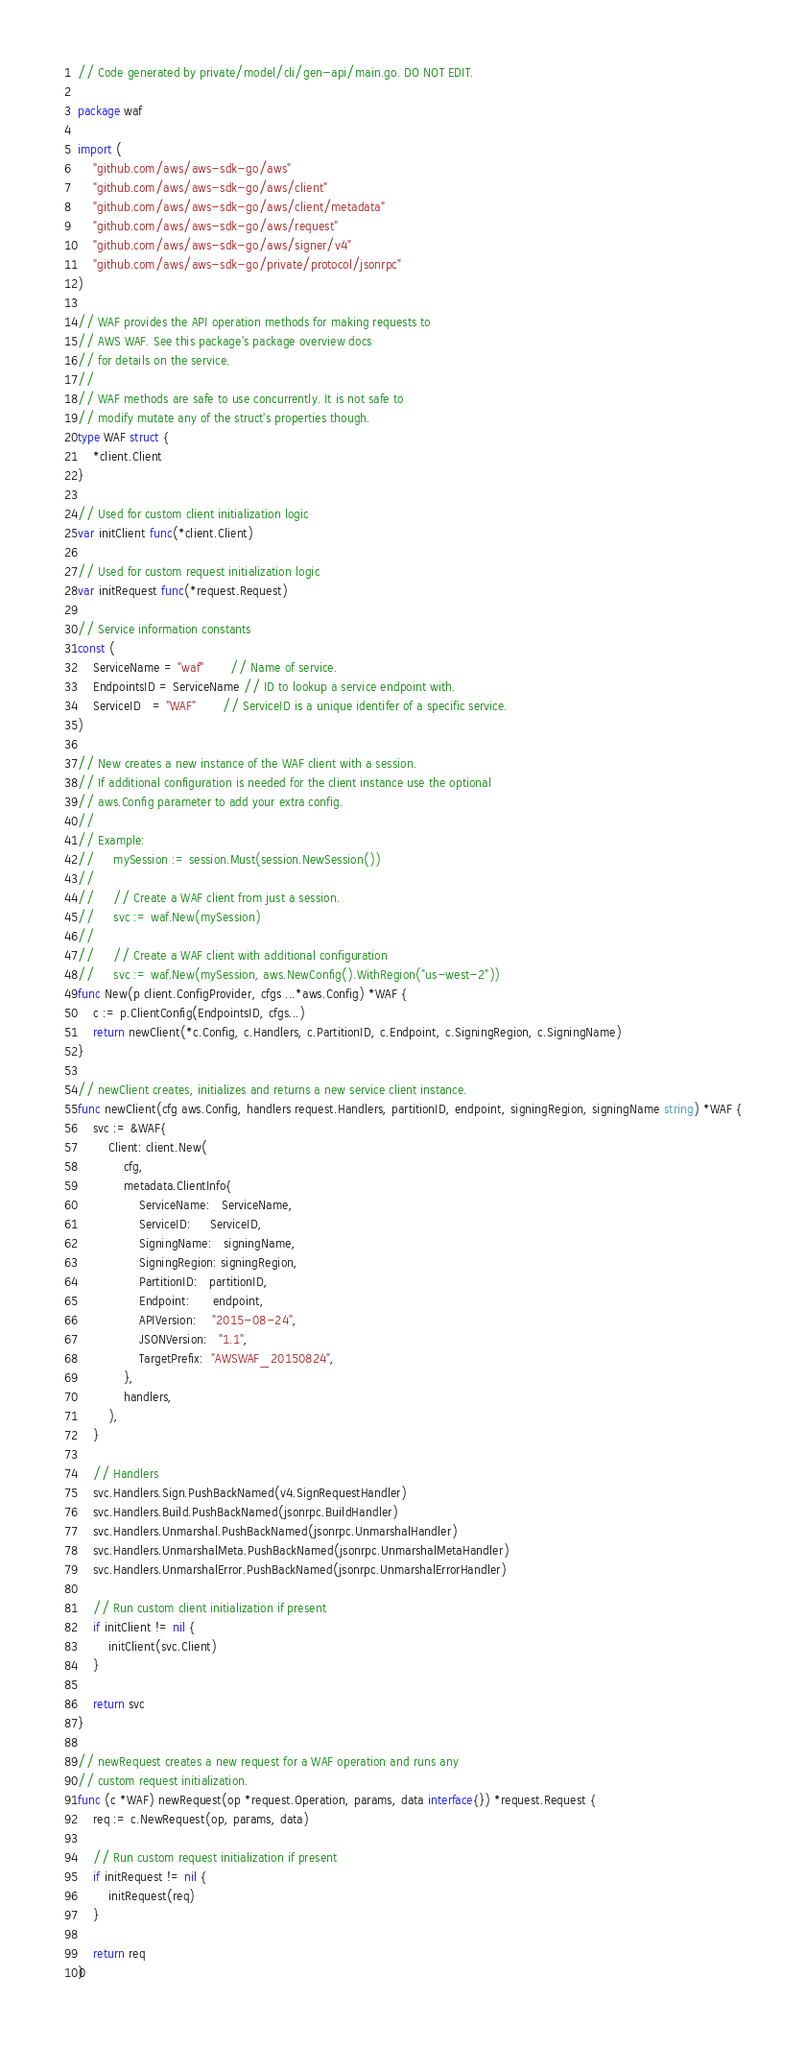Convert code to text. <code><loc_0><loc_0><loc_500><loc_500><_Go_>// Code generated by private/model/cli/gen-api/main.go. DO NOT EDIT.

package waf

import (
	"github.com/aws/aws-sdk-go/aws"
	"github.com/aws/aws-sdk-go/aws/client"
	"github.com/aws/aws-sdk-go/aws/client/metadata"
	"github.com/aws/aws-sdk-go/aws/request"
	"github.com/aws/aws-sdk-go/aws/signer/v4"
	"github.com/aws/aws-sdk-go/private/protocol/jsonrpc"
)

// WAF provides the API operation methods for making requests to
// AWS WAF. See this package's package overview docs
// for details on the service.
//
// WAF methods are safe to use concurrently. It is not safe to
// modify mutate any of the struct's properties though.
type WAF struct {
	*client.Client
}

// Used for custom client initialization logic
var initClient func(*client.Client)

// Used for custom request initialization logic
var initRequest func(*request.Request)

// Service information constants
const (
	ServiceName = "waf"       // Name of service.
	EndpointsID = ServiceName // ID to lookup a service endpoint with.
	ServiceID   = "WAF"       // ServiceID is a unique identifer of a specific service.
)

// New creates a new instance of the WAF client with a session.
// If additional configuration is needed for the client instance use the optional
// aws.Config parameter to add your extra config.
//
// Example:
//     mySession := session.Must(session.NewSession())
//
//     // Create a WAF client from just a session.
//     svc := waf.New(mySession)
//
//     // Create a WAF client with additional configuration
//     svc := waf.New(mySession, aws.NewConfig().WithRegion("us-west-2"))
func New(p client.ConfigProvider, cfgs ...*aws.Config) *WAF {
	c := p.ClientConfig(EndpointsID, cfgs...)
	return newClient(*c.Config, c.Handlers, c.PartitionID, c.Endpoint, c.SigningRegion, c.SigningName)
}

// newClient creates, initializes and returns a new service client instance.
func newClient(cfg aws.Config, handlers request.Handlers, partitionID, endpoint, signingRegion, signingName string) *WAF {
	svc := &WAF{
		Client: client.New(
			cfg,
			metadata.ClientInfo{
				ServiceName:   ServiceName,
				ServiceID:     ServiceID,
				SigningName:   signingName,
				SigningRegion: signingRegion,
				PartitionID:   partitionID,
				Endpoint:      endpoint,
				APIVersion:    "2015-08-24",
				JSONVersion:   "1.1",
				TargetPrefix:  "AWSWAF_20150824",
			},
			handlers,
		),
	}

	// Handlers
	svc.Handlers.Sign.PushBackNamed(v4.SignRequestHandler)
	svc.Handlers.Build.PushBackNamed(jsonrpc.BuildHandler)
	svc.Handlers.Unmarshal.PushBackNamed(jsonrpc.UnmarshalHandler)
	svc.Handlers.UnmarshalMeta.PushBackNamed(jsonrpc.UnmarshalMetaHandler)
	svc.Handlers.UnmarshalError.PushBackNamed(jsonrpc.UnmarshalErrorHandler)

	// Run custom client initialization if present
	if initClient != nil {
		initClient(svc.Client)
	}

	return svc
}

// newRequest creates a new request for a WAF operation and runs any
// custom request initialization.
func (c *WAF) newRequest(op *request.Operation, params, data interface{}) *request.Request {
	req := c.NewRequest(op, params, data)

	// Run custom request initialization if present
	if initRequest != nil {
		initRequest(req)
	}

	return req
}
</code> 